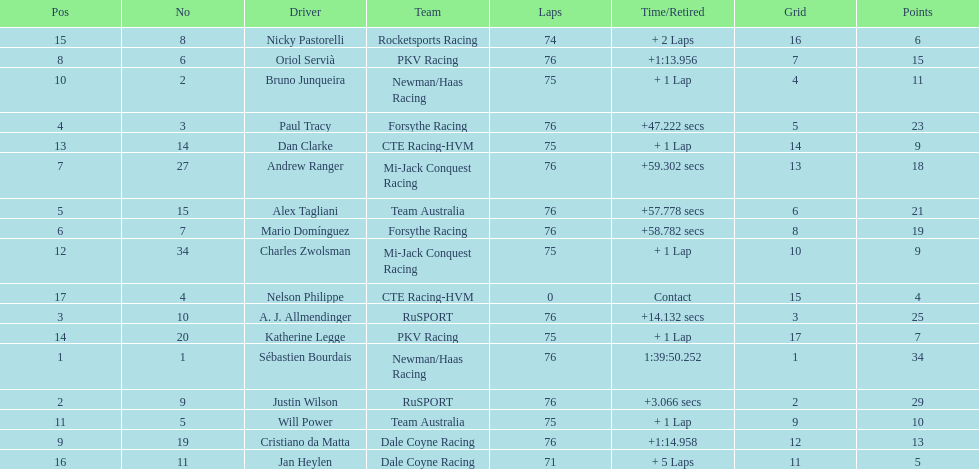What is the total point difference between the driver who received the most points and the driver who received the least? 30. 